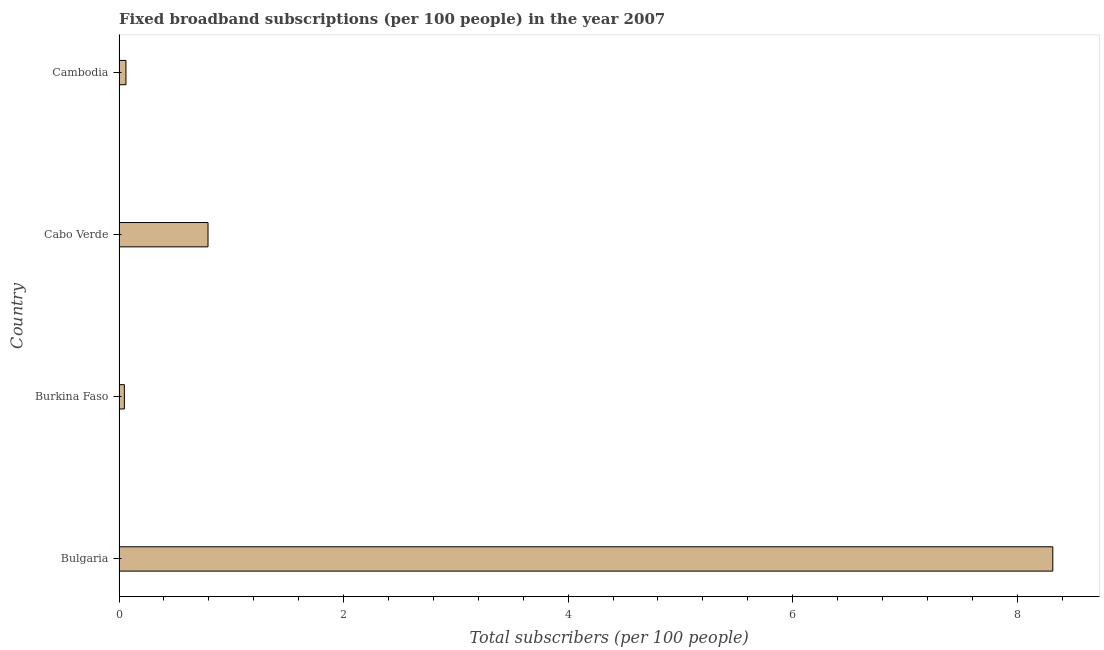Does the graph contain grids?
Provide a succinct answer. No. What is the title of the graph?
Keep it short and to the point. Fixed broadband subscriptions (per 100 people) in the year 2007. What is the label or title of the X-axis?
Offer a very short reply. Total subscribers (per 100 people). What is the label or title of the Y-axis?
Ensure brevity in your answer.  Country. What is the total number of fixed broadband subscriptions in Bulgaria?
Your answer should be compact. 8.32. Across all countries, what is the maximum total number of fixed broadband subscriptions?
Your answer should be very brief. 8.32. Across all countries, what is the minimum total number of fixed broadband subscriptions?
Offer a very short reply. 0.05. In which country was the total number of fixed broadband subscriptions minimum?
Give a very brief answer. Burkina Faso. What is the sum of the total number of fixed broadband subscriptions?
Keep it short and to the point. 9.22. What is the difference between the total number of fixed broadband subscriptions in Bulgaria and Cambodia?
Make the answer very short. 8.26. What is the average total number of fixed broadband subscriptions per country?
Offer a terse response. 2.31. What is the median total number of fixed broadband subscriptions?
Give a very brief answer. 0.43. What is the ratio of the total number of fixed broadband subscriptions in Bulgaria to that in Cabo Verde?
Your answer should be compact. 10.5. Is the total number of fixed broadband subscriptions in Burkina Faso less than that in Cambodia?
Keep it short and to the point. Yes. Is the difference between the total number of fixed broadband subscriptions in Bulgaria and Cabo Verde greater than the difference between any two countries?
Your answer should be very brief. No. What is the difference between the highest and the second highest total number of fixed broadband subscriptions?
Keep it short and to the point. 7.53. What is the difference between the highest and the lowest total number of fixed broadband subscriptions?
Offer a terse response. 8.27. Are all the bars in the graph horizontal?
Offer a very short reply. Yes. What is the Total subscribers (per 100 people) in Bulgaria?
Your response must be concise. 8.32. What is the Total subscribers (per 100 people) of Burkina Faso?
Ensure brevity in your answer.  0.05. What is the Total subscribers (per 100 people) in Cabo Verde?
Your answer should be very brief. 0.79. What is the Total subscribers (per 100 people) in Cambodia?
Offer a terse response. 0.06. What is the difference between the Total subscribers (per 100 people) in Bulgaria and Burkina Faso?
Your answer should be very brief. 8.27. What is the difference between the Total subscribers (per 100 people) in Bulgaria and Cabo Verde?
Offer a terse response. 7.53. What is the difference between the Total subscribers (per 100 people) in Bulgaria and Cambodia?
Give a very brief answer. 8.26. What is the difference between the Total subscribers (per 100 people) in Burkina Faso and Cabo Verde?
Offer a terse response. -0.75. What is the difference between the Total subscribers (per 100 people) in Burkina Faso and Cambodia?
Your answer should be very brief. -0.01. What is the difference between the Total subscribers (per 100 people) in Cabo Verde and Cambodia?
Your answer should be very brief. 0.73. What is the ratio of the Total subscribers (per 100 people) in Bulgaria to that in Burkina Faso?
Your answer should be compact. 175.88. What is the ratio of the Total subscribers (per 100 people) in Bulgaria to that in Cabo Verde?
Provide a succinct answer. 10.5. What is the ratio of the Total subscribers (per 100 people) in Bulgaria to that in Cambodia?
Provide a short and direct response. 135.32. What is the ratio of the Total subscribers (per 100 people) in Burkina Faso to that in Cabo Verde?
Provide a short and direct response. 0.06. What is the ratio of the Total subscribers (per 100 people) in Burkina Faso to that in Cambodia?
Make the answer very short. 0.77. What is the ratio of the Total subscribers (per 100 people) in Cabo Verde to that in Cambodia?
Provide a succinct answer. 12.89. 